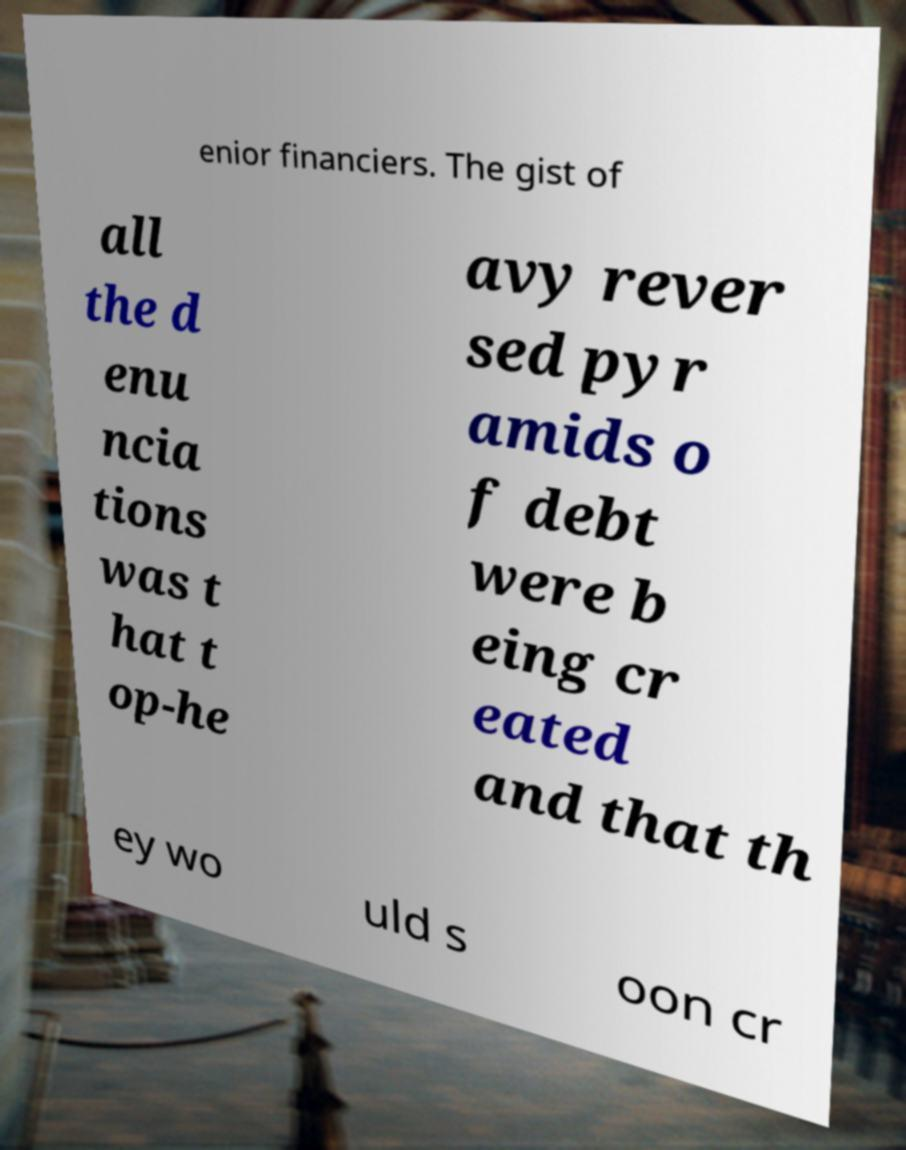Please identify and transcribe the text found in this image. enior financiers. The gist of all the d enu ncia tions was t hat t op-he avy rever sed pyr amids o f debt were b eing cr eated and that th ey wo uld s oon cr 